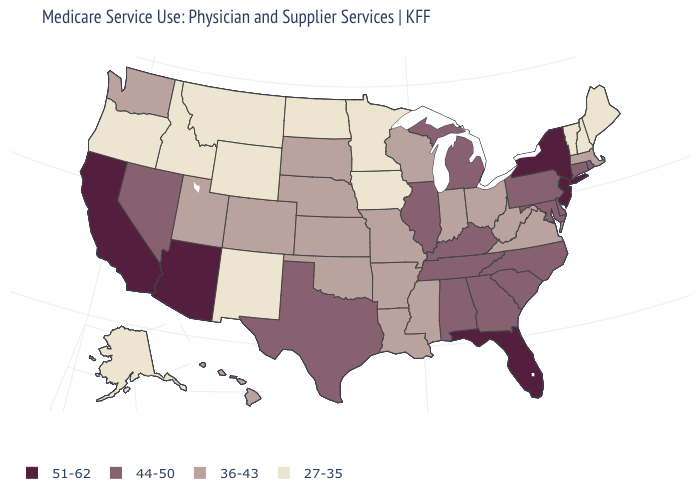Name the states that have a value in the range 36-43?
Answer briefly. Arkansas, Colorado, Hawaii, Indiana, Kansas, Louisiana, Massachusetts, Mississippi, Missouri, Nebraska, Ohio, Oklahoma, South Dakota, Utah, Virginia, Washington, West Virginia, Wisconsin. Name the states that have a value in the range 51-62?
Answer briefly. Arizona, California, Florida, New Jersey, New York. What is the value of Pennsylvania?
Keep it brief. 44-50. What is the lowest value in the USA?
Concise answer only. 27-35. Does the map have missing data?
Quick response, please. No. Name the states that have a value in the range 27-35?
Answer briefly. Alaska, Idaho, Iowa, Maine, Minnesota, Montana, New Hampshire, New Mexico, North Dakota, Oregon, Vermont, Wyoming. Does New York have the lowest value in the Northeast?
Write a very short answer. No. Name the states that have a value in the range 44-50?
Short answer required. Alabama, Connecticut, Delaware, Georgia, Illinois, Kentucky, Maryland, Michigan, Nevada, North Carolina, Pennsylvania, Rhode Island, South Carolina, Tennessee, Texas. Which states have the lowest value in the MidWest?
Be succinct. Iowa, Minnesota, North Dakota. Does Minnesota have the lowest value in the USA?
Give a very brief answer. Yes. Among the states that border California , which have the lowest value?
Be succinct. Oregon. Does Pennsylvania have the highest value in the Northeast?
Be succinct. No. Name the states that have a value in the range 27-35?
Short answer required. Alaska, Idaho, Iowa, Maine, Minnesota, Montana, New Hampshire, New Mexico, North Dakota, Oregon, Vermont, Wyoming. Which states have the highest value in the USA?
Quick response, please. Arizona, California, Florida, New Jersey, New York. Name the states that have a value in the range 27-35?
Answer briefly. Alaska, Idaho, Iowa, Maine, Minnesota, Montana, New Hampshire, New Mexico, North Dakota, Oregon, Vermont, Wyoming. 